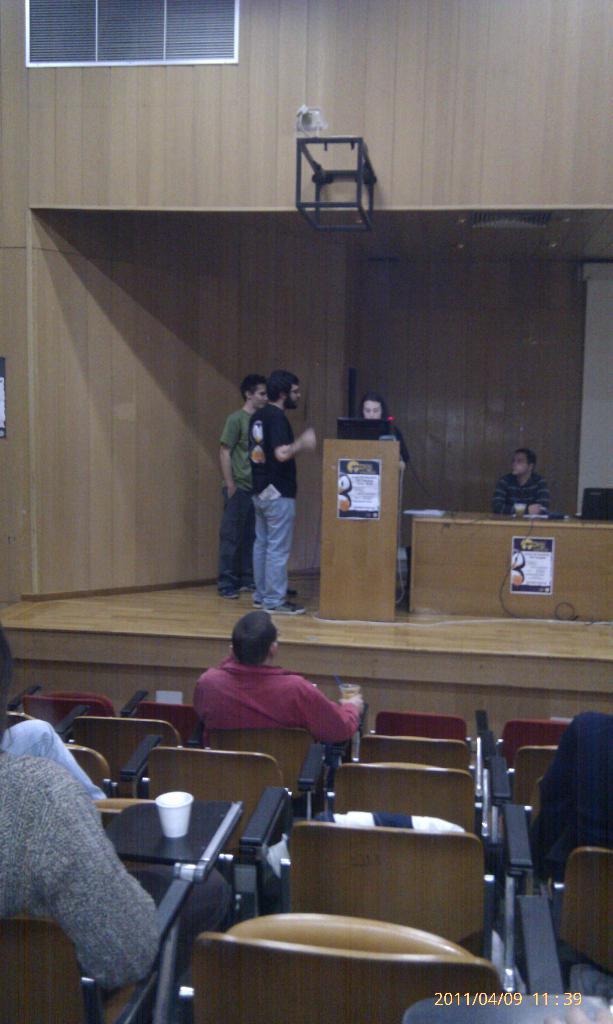Please provide a concise description of this image. Few persons are sitting on the chairs and few persons are standing. We can see chairs,tables and laptop on the podium. On the background we can see wall,window. 